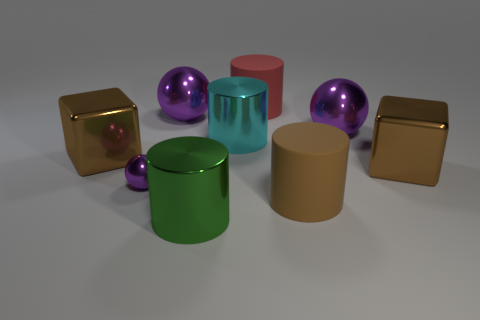There is a rubber cylinder that is behind the metallic cube to the left of the large green metallic cylinder; what color is it?
Offer a very short reply. Red. Are there fewer red rubber cylinders that are in front of the large brown cylinder than purple spheres to the right of the cyan cylinder?
Keep it short and to the point. Yes. What number of objects are metallic things that are to the left of the tiny ball or big cubes?
Make the answer very short. 2. Does the purple thing to the right of the cyan cylinder have the same size as the brown matte cylinder?
Keep it short and to the point. Yes. Is the number of purple objects in front of the small object less than the number of small gray matte cubes?
Ensure brevity in your answer.  No. There is a cyan cylinder that is the same size as the red matte cylinder; what material is it?
Offer a terse response. Metal. How many big things are either green metallic objects or purple things?
Offer a very short reply. 3. How many things are big metallic cubes that are right of the red thing or big cylinders behind the small purple metal thing?
Provide a succinct answer. 3. Is the number of shiny cylinders less than the number of red things?
Give a very brief answer. No. There is a red thing that is the same size as the green metal thing; what is its shape?
Provide a succinct answer. Cylinder. 